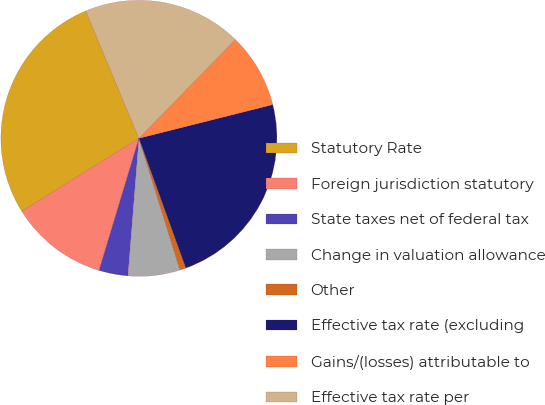Convert chart. <chart><loc_0><loc_0><loc_500><loc_500><pie_chart><fcel>Statutory Rate<fcel>Foreign jurisdiction statutory<fcel>State taxes net of federal tax<fcel>Change in valuation allowance<fcel>Other<fcel>Effective tax rate (excluding<fcel>Gains/(losses) attributable to<fcel>Effective tax rate per<nl><fcel>27.58%<fcel>11.46%<fcel>3.4%<fcel>6.08%<fcel>0.71%<fcel>23.4%<fcel>8.77%<fcel>18.6%<nl></chart> 